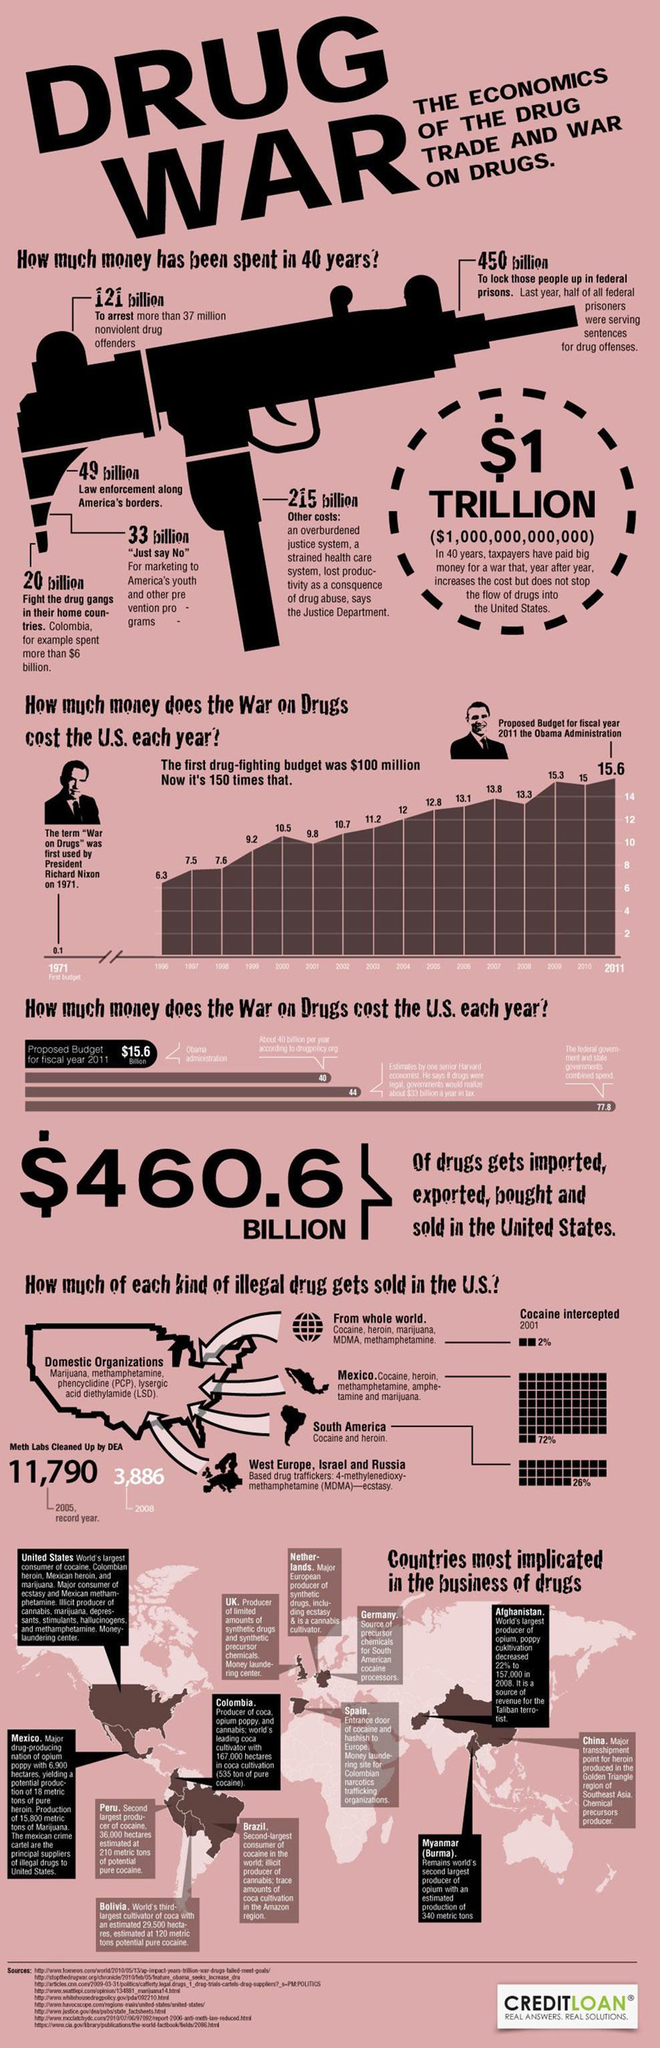What is the total expenses occurred in the last forty years in the fight against drug abuse?
Answer the question with a short phrase. 888 billion Which country is highest cultivator of Opium, Germany, Afghanistan, or Myanmar? Afghanistan What is the difference in the drug fighting budget allocated in the year 2002 and 2011 in millions? 5.1 million Which country is first in the production of Coca, Colombia, Spain, or Mexico? Colombia Which American presidents images are given in the document? Richard Nixon, Obama What percentage of drugs from South America is sold in the US, 72%, 26%, or 2%? 26% Which country sells the highest percentage of drugs in the US? Mexico How many countries are implicated in the drug business? 13 